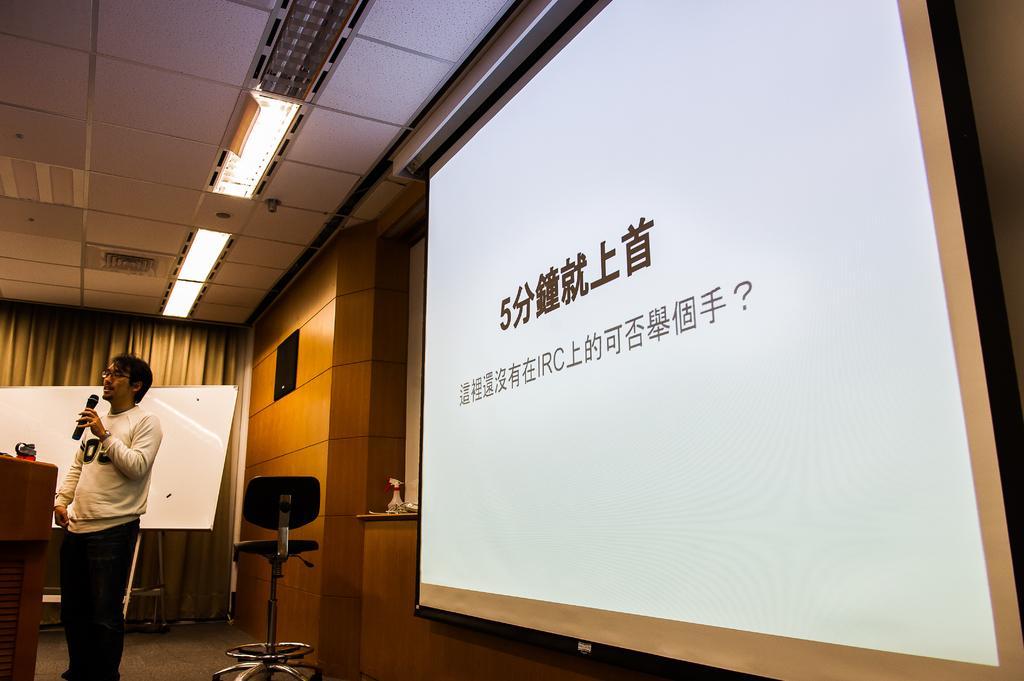Can you describe this image briefly? This picture might be taken from the conference hall. In this image, on the left side, we can see a man wearing a white color shirt is standing and holding a microphone in his hand. On the left side, we can also see a podium. On the right side, we can see a screen, in the screen, we can see some text written on it. In the middle of the image, we can see a chair. In the background, we can also see a white color board, curtains. On the right side, we can also see a table, on the table, we can see a bottle. At the top, we can see a roof with few lights. 